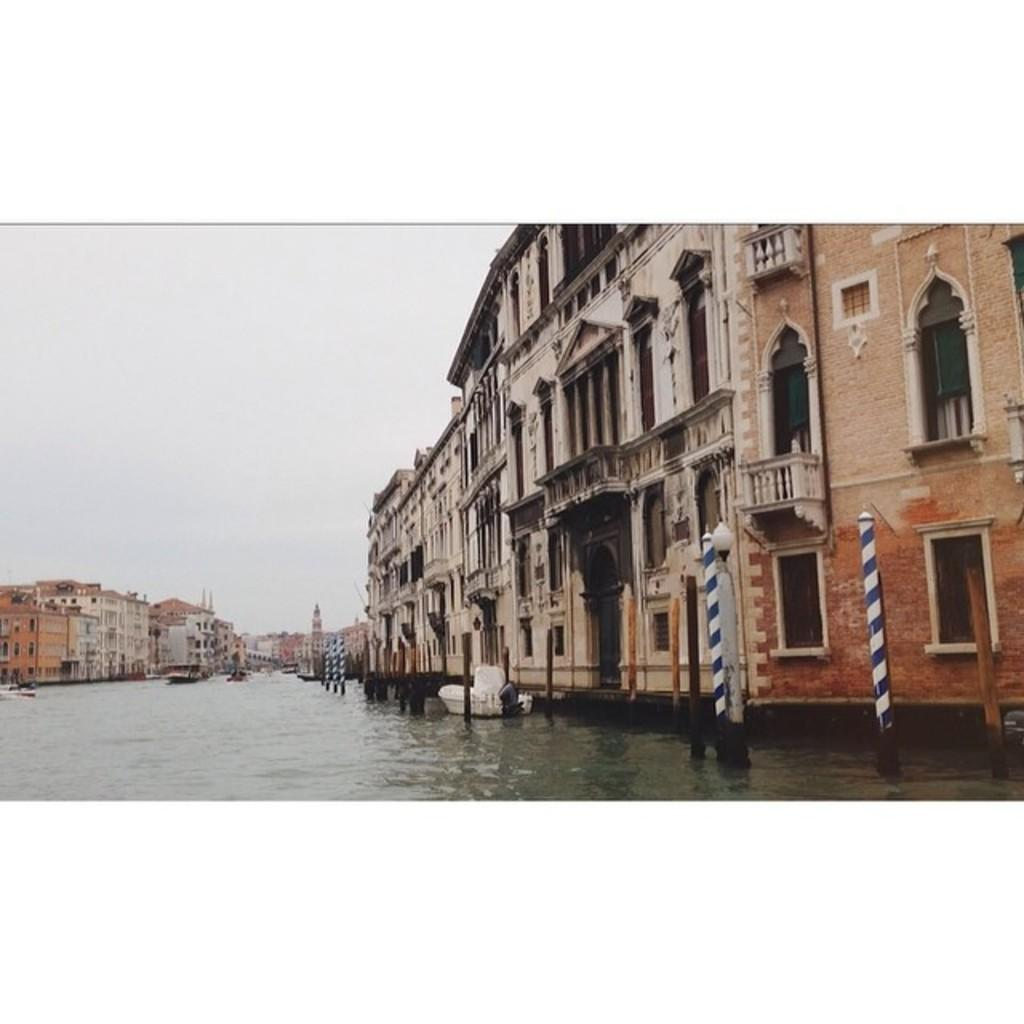What type of structures can be seen in the image? There are buildings in the image. What feature is common to many of the buildings? There are windows in the buildings. What are the poles used for in the image? The poles are light poles, which provide illumination. What part of the natural environment is visible in the image? The sky and water are visible in the image. How many wings can be seen on the island in the image? There is no island present in the image, and therefore no wings associated with it. 